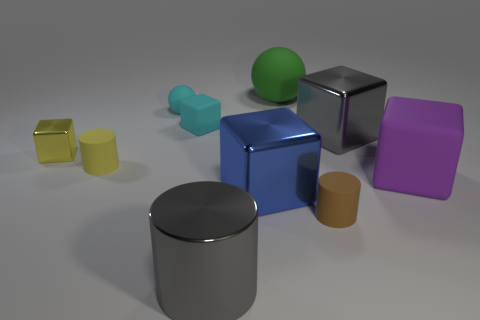Subtract all gray cubes. How many cubes are left? 4 Subtract all purple matte cubes. How many cubes are left? 4 Subtract all red blocks. Subtract all green cylinders. How many blocks are left? 5 Subtract all cylinders. How many objects are left? 7 Add 5 tiny blue metallic things. How many tiny blue metallic things exist? 5 Subtract 0 gray balls. How many objects are left? 10 Subtract all yellow metal spheres. Subtract all purple matte blocks. How many objects are left? 9 Add 6 green matte balls. How many green matte balls are left? 7 